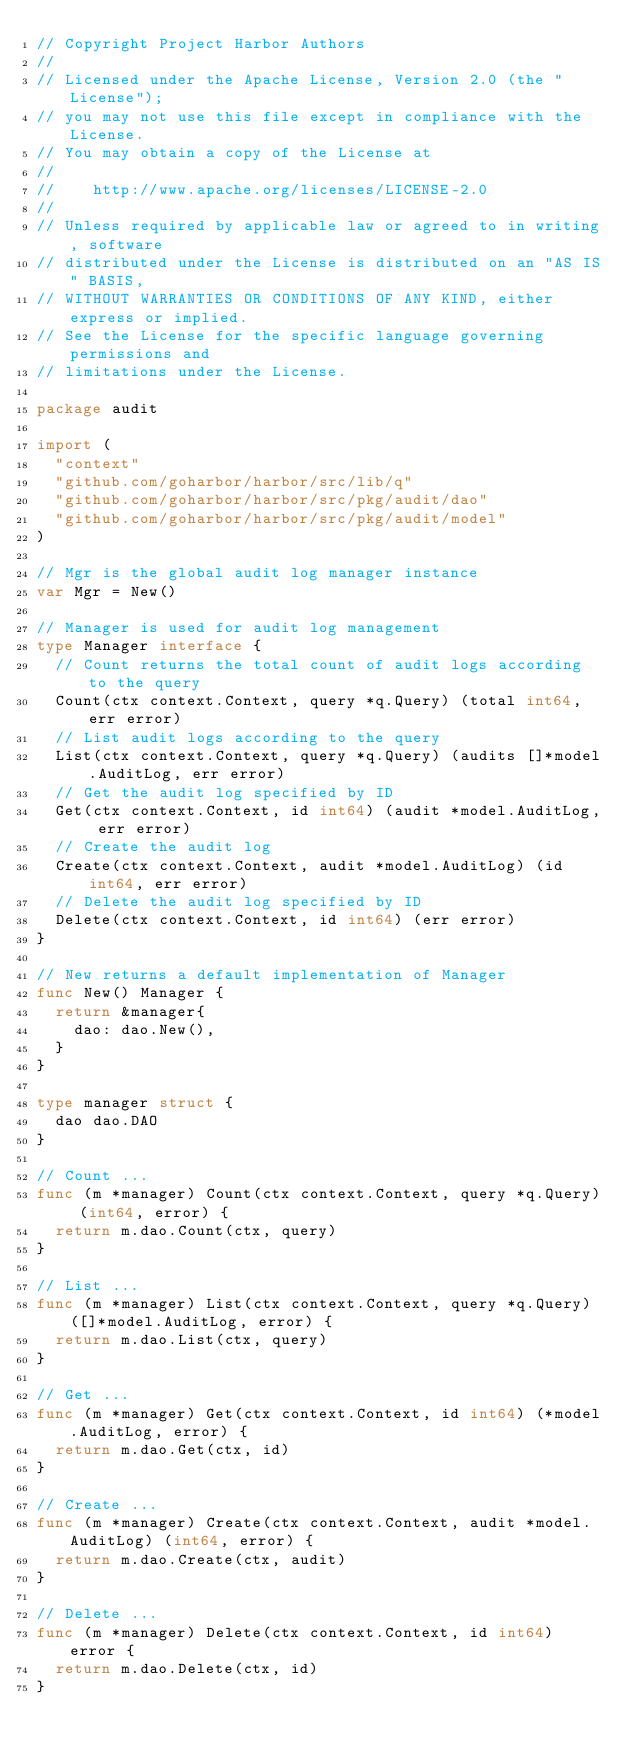<code> <loc_0><loc_0><loc_500><loc_500><_Go_>// Copyright Project Harbor Authors
//
// Licensed under the Apache License, Version 2.0 (the "License");
// you may not use this file except in compliance with the License.
// You may obtain a copy of the License at
//
//    http://www.apache.org/licenses/LICENSE-2.0
//
// Unless required by applicable law or agreed to in writing, software
// distributed under the License is distributed on an "AS IS" BASIS,
// WITHOUT WARRANTIES OR CONDITIONS OF ANY KIND, either express or implied.
// See the License for the specific language governing permissions and
// limitations under the License.

package audit

import (
	"context"
	"github.com/goharbor/harbor/src/lib/q"
	"github.com/goharbor/harbor/src/pkg/audit/dao"
	"github.com/goharbor/harbor/src/pkg/audit/model"
)

// Mgr is the global audit log manager instance
var Mgr = New()

// Manager is used for audit log management
type Manager interface {
	// Count returns the total count of audit logs according to the query
	Count(ctx context.Context, query *q.Query) (total int64, err error)
	// List audit logs according to the query
	List(ctx context.Context, query *q.Query) (audits []*model.AuditLog, err error)
	// Get the audit log specified by ID
	Get(ctx context.Context, id int64) (audit *model.AuditLog, err error)
	// Create the audit log
	Create(ctx context.Context, audit *model.AuditLog) (id int64, err error)
	// Delete the audit log specified by ID
	Delete(ctx context.Context, id int64) (err error)
}

// New returns a default implementation of Manager
func New() Manager {
	return &manager{
		dao: dao.New(),
	}
}

type manager struct {
	dao dao.DAO
}

// Count ...
func (m *manager) Count(ctx context.Context, query *q.Query) (int64, error) {
	return m.dao.Count(ctx, query)
}

// List ...
func (m *manager) List(ctx context.Context, query *q.Query) ([]*model.AuditLog, error) {
	return m.dao.List(ctx, query)
}

// Get ...
func (m *manager) Get(ctx context.Context, id int64) (*model.AuditLog, error) {
	return m.dao.Get(ctx, id)
}

// Create ...
func (m *manager) Create(ctx context.Context, audit *model.AuditLog) (int64, error) {
	return m.dao.Create(ctx, audit)
}

// Delete ...
func (m *manager) Delete(ctx context.Context, id int64) error {
	return m.dao.Delete(ctx, id)
}
</code> 